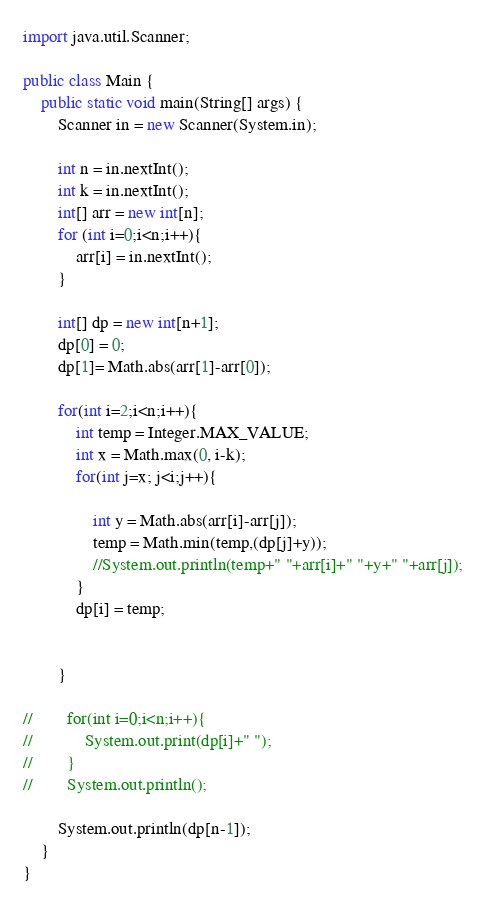Convert code to text. <code><loc_0><loc_0><loc_500><loc_500><_Java_>import java.util.Scanner;

public class Main {
    public static void main(String[] args) {
        Scanner in = new Scanner(System.in);

        int n = in.nextInt();
        int k = in.nextInt();
        int[] arr = new int[n];
        for (int i=0;i<n;i++){
            arr[i] = in.nextInt();
        }

        int[] dp = new int[n+1];
        dp[0] = 0;
        dp[1]= Math.abs(arr[1]-arr[0]);

        for(int i=2;i<n;i++){
            int temp = Integer.MAX_VALUE;
            int x = Math.max(0, i-k);
            for(int j=x; j<i;j++){

                int y = Math.abs(arr[i]-arr[j]);
                temp = Math.min(temp,(dp[j]+y));
                //System.out.println(temp+" "+arr[i]+" "+y+" "+arr[j]);
            }
            dp[i] = temp;


        }

//        for(int i=0;i<n;i++){
//            System.out.print(dp[i]+" ");
//        }
//        System.out.println();

        System.out.println(dp[n-1]);
    }
}
</code> 